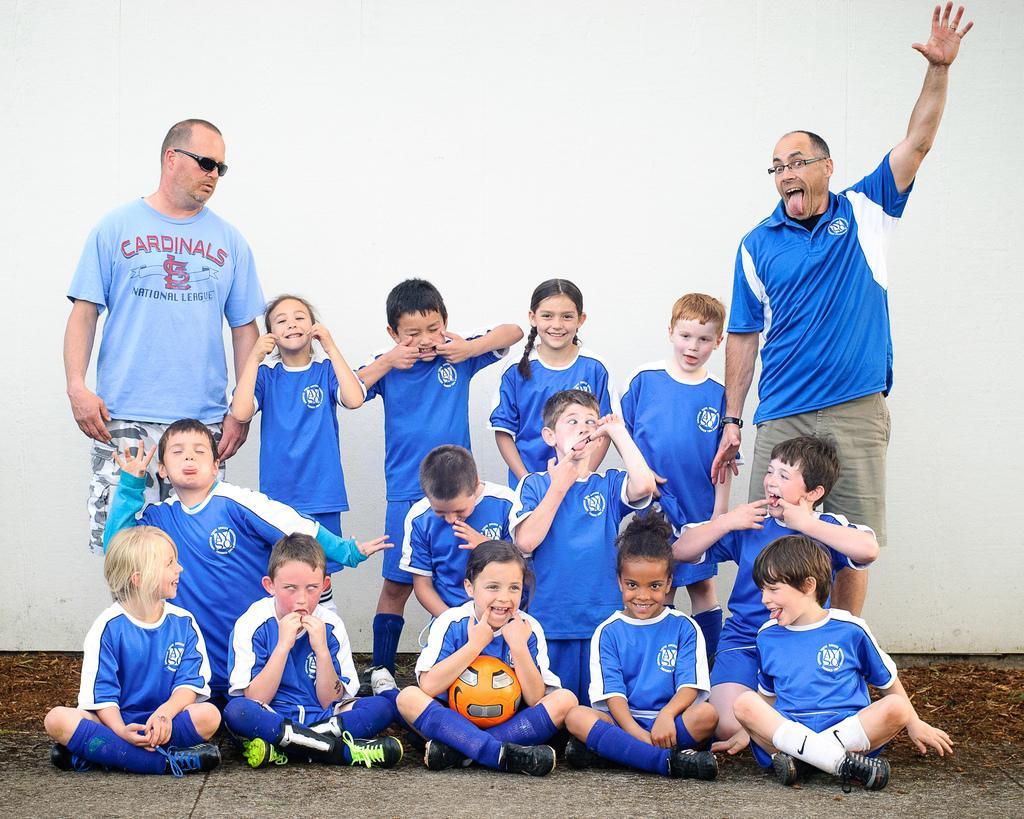Can you describe this image briefly? In this image we can see people standing and some of them are sitting. There is a ball. At the bottom there is a floor. In the background there is a wall. 